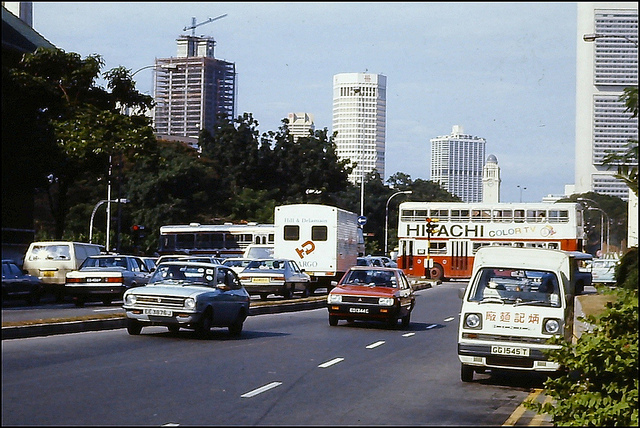<image>What insignia is on the truck? I am not sure what insignia is on the truck. It could be 'hitachi', 'chinese letters' or 'numbers'. What type of construction equipment on top of the building? I am not sure what type of construction equipment is on top of the building, but it can be a crane. What insignia is on the truck? I don't know what insignia is on the truck. It can be either 'Hitachi' or 'Chinese letters'. What type of construction equipment on top of the building? The type of construction equipment on top of the building is a crane. 